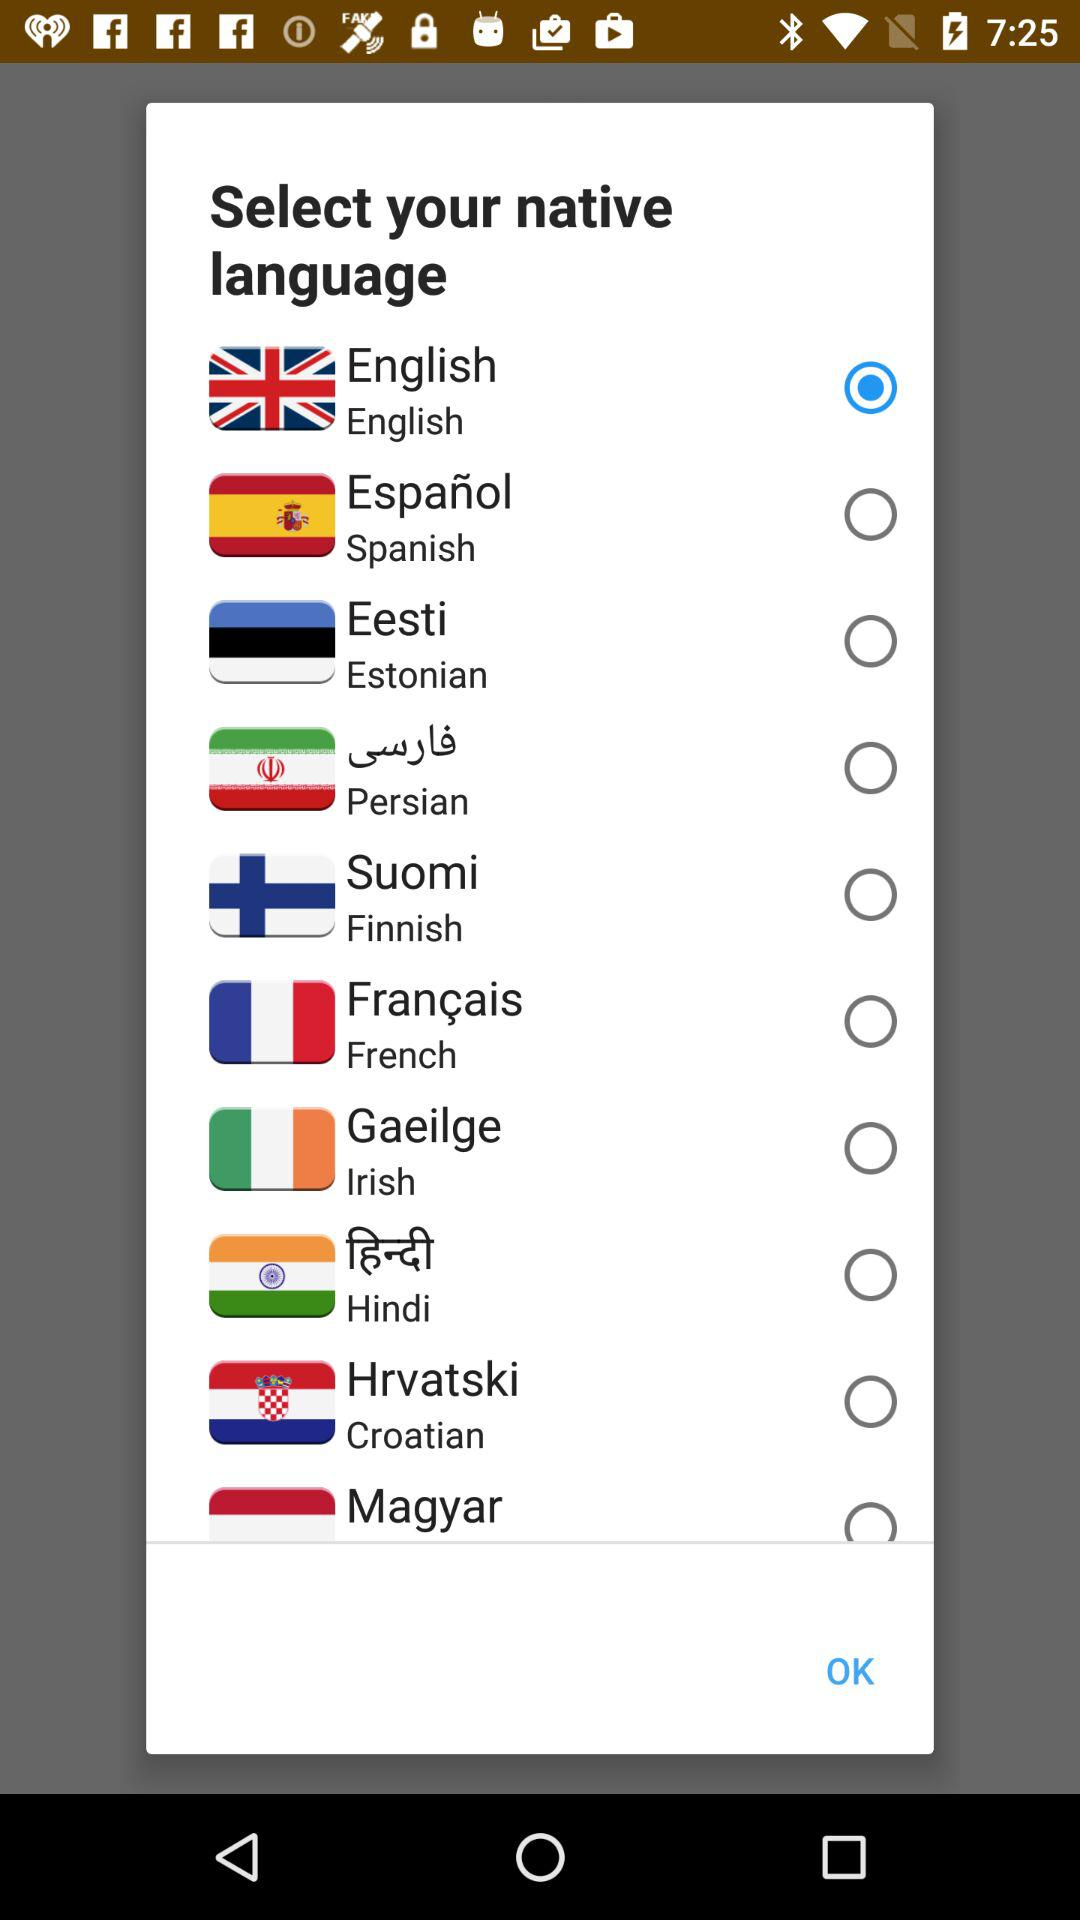Which language is selected? The selected language is English. 